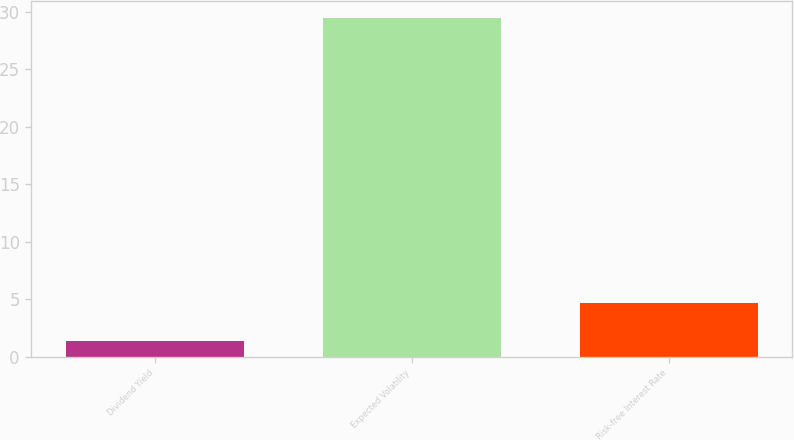Convert chart. <chart><loc_0><loc_0><loc_500><loc_500><bar_chart><fcel>Dividend Yield<fcel>Expected Volatility<fcel>Risk-free Interest Rate<nl><fcel>1.32<fcel>29.44<fcel>4.68<nl></chart> 